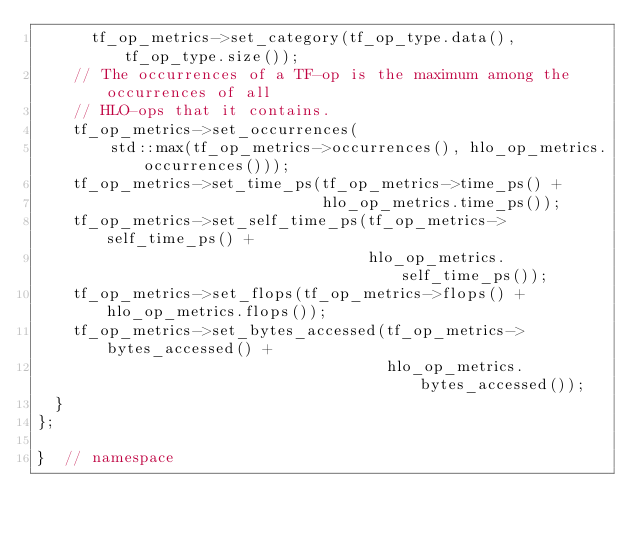<code> <loc_0><loc_0><loc_500><loc_500><_C++_>      tf_op_metrics->set_category(tf_op_type.data(), tf_op_type.size());
    // The occurrences of a TF-op is the maximum among the occurrences of all
    // HLO-ops that it contains.
    tf_op_metrics->set_occurrences(
        std::max(tf_op_metrics->occurrences(), hlo_op_metrics.occurrences()));
    tf_op_metrics->set_time_ps(tf_op_metrics->time_ps() +
                               hlo_op_metrics.time_ps());
    tf_op_metrics->set_self_time_ps(tf_op_metrics->self_time_ps() +
                                    hlo_op_metrics.self_time_ps());
    tf_op_metrics->set_flops(tf_op_metrics->flops() + hlo_op_metrics.flops());
    tf_op_metrics->set_bytes_accessed(tf_op_metrics->bytes_accessed() +
                                      hlo_op_metrics.bytes_accessed());
  }
};

}  // namespace
</code> 